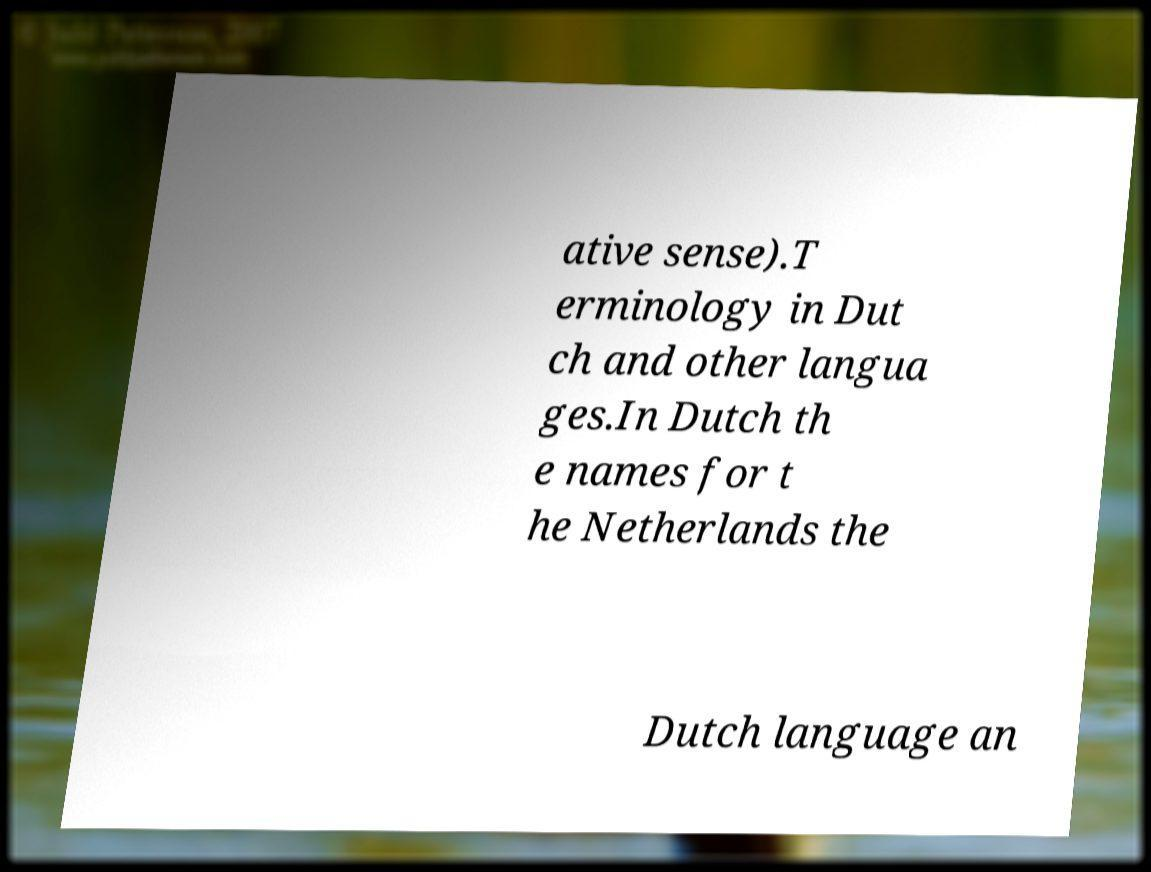There's text embedded in this image that I need extracted. Can you transcribe it verbatim? ative sense).T erminology in Dut ch and other langua ges.In Dutch th e names for t he Netherlands the Dutch language an 